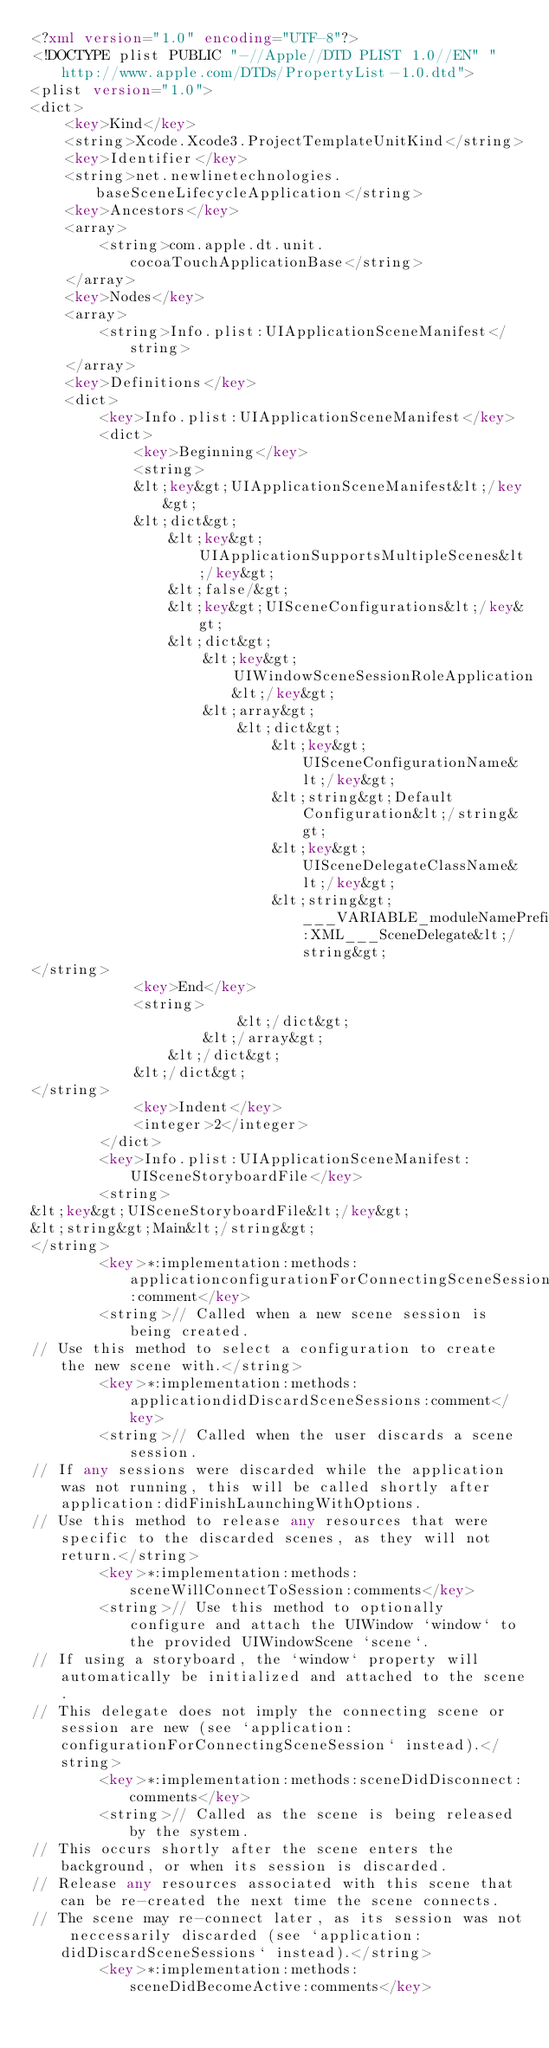<code> <loc_0><loc_0><loc_500><loc_500><_XML_><?xml version="1.0" encoding="UTF-8"?>
<!DOCTYPE plist PUBLIC "-//Apple//DTD PLIST 1.0//EN" "http://www.apple.com/DTDs/PropertyList-1.0.dtd">
<plist version="1.0">
<dict>
	<key>Kind</key>
	<string>Xcode.Xcode3.ProjectTemplateUnitKind</string>
	<key>Identifier</key>
	<string>net.newlinetechnologies.baseSceneLifecycleApplication</string>
	<key>Ancestors</key>
	<array>
		<string>com.apple.dt.unit.cocoaTouchApplicationBase</string>
	</array>
	<key>Nodes</key>
	<array>
		<string>Info.plist:UIApplicationSceneManifest</string>
	</array>
	<key>Definitions</key>
	<dict>
		<key>Info.plist:UIApplicationSceneManifest</key>
		<dict>
			<key>Beginning</key>
			<string>
            &lt;key&gt;UIApplicationSceneManifest&lt;/key&gt;
            &lt;dict&gt;
                &lt;key&gt;UIApplicationSupportsMultipleScenes&lt;/key&gt;
                &lt;false/&gt;
                &lt;key&gt;UISceneConfigurations&lt;/key&gt;
                &lt;dict&gt;
                    &lt;key&gt;UIWindowSceneSessionRoleApplication&lt;/key&gt;
                    &lt;array&gt;
                        &lt;dict&gt;
                            &lt;key&gt;UISceneConfigurationName&lt;/key&gt;
                            &lt;string&gt;Default Configuration&lt;/string&gt;
                            &lt;key&gt;UISceneDelegateClassName&lt;/key&gt;
                            &lt;string&gt;___VARIABLE_moduleNamePrefixForClasses:XML___SceneDelegate&lt;/string&gt;
</string>
			<key>End</key>
			<string>
                        &lt;/dict&gt;
                    &lt;/array&gt;
                &lt;/dict&gt;
            &lt;/dict&gt;
</string>
			<key>Indent</key>
			<integer>2</integer>
		</dict>
		<key>Info.plist:UIApplicationSceneManifest:UISceneStoryboardFile</key>
		<string>
&lt;key&gt;UISceneStoryboardFile&lt;/key&gt;
&lt;string&gt;Main&lt;/string&gt;
</string>
		<key>*:implementation:methods:applicationconfigurationForConnectingSceneSession:comment</key>
		<string>// Called when a new scene session is being created.
// Use this method to select a configuration to create the new scene with.</string>
		<key>*:implementation:methods:applicationdidDiscardSceneSessions:comment</key>
		<string>// Called when the user discards a scene session.
// If any sessions were discarded while the application was not running, this will be called shortly after application:didFinishLaunchingWithOptions.
// Use this method to release any resources that were specific to the discarded scenes, as they will not return.</string>
		<key>*:implementation:methods:sceneWillConnectToSession:comments</key>
		<string>// Use this method to optionally configure and attach the UIWindow `window` to the provided UIWindowScene `scene`.
// If using a storyboard, the `window` property will automatically be initialized and attached to the scene.
// This delegate does not imply the connecting scene or session are new (see `application:configurationForConnectingSceneSession` instead).</string>
		<key>*:implementation:methods:sceneDidDisconnect:comments</key>
		<string>// Called as the scene is being released by the system.
// This occurs shortly after the scene enters the background, or when its session is discarded.
// Release any resources associated with this scene that can be re-created the next time the scene connects.
// The scene may re-connect later, as its session was not neccessarily discarded (see `application:didDiscardSceneSessions` instead).</string>
		<key>*:implementation:methods:sceneDidBecomeActive:comments</key></code> 